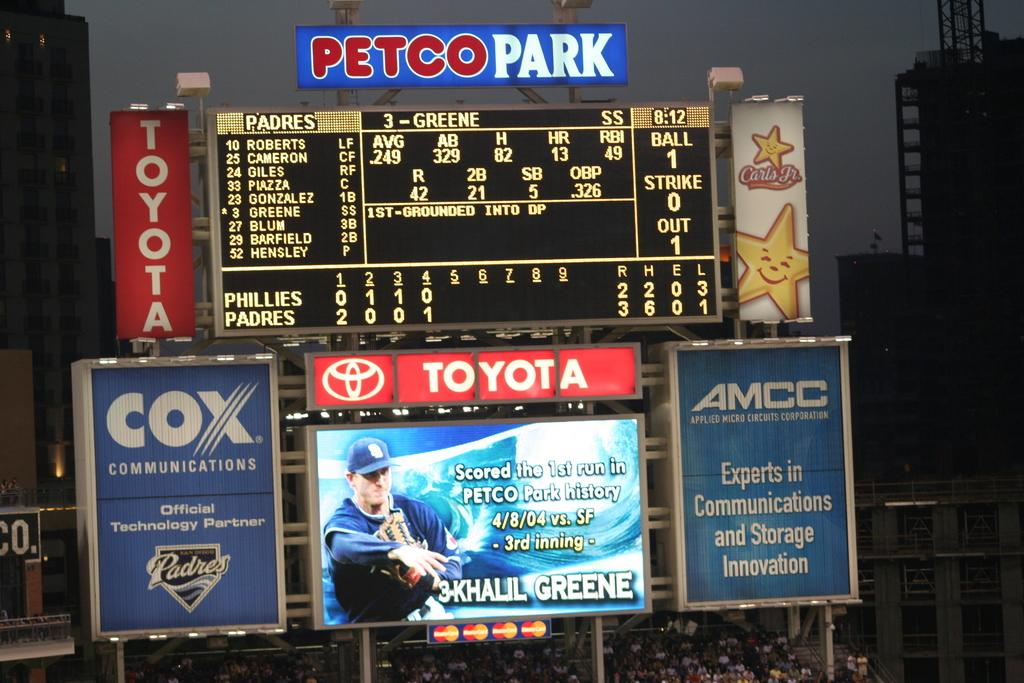<image>
Render a clear and concise summary of the photo. The scoreboard at Petco Park shows the Phillies are playing the Padres. 